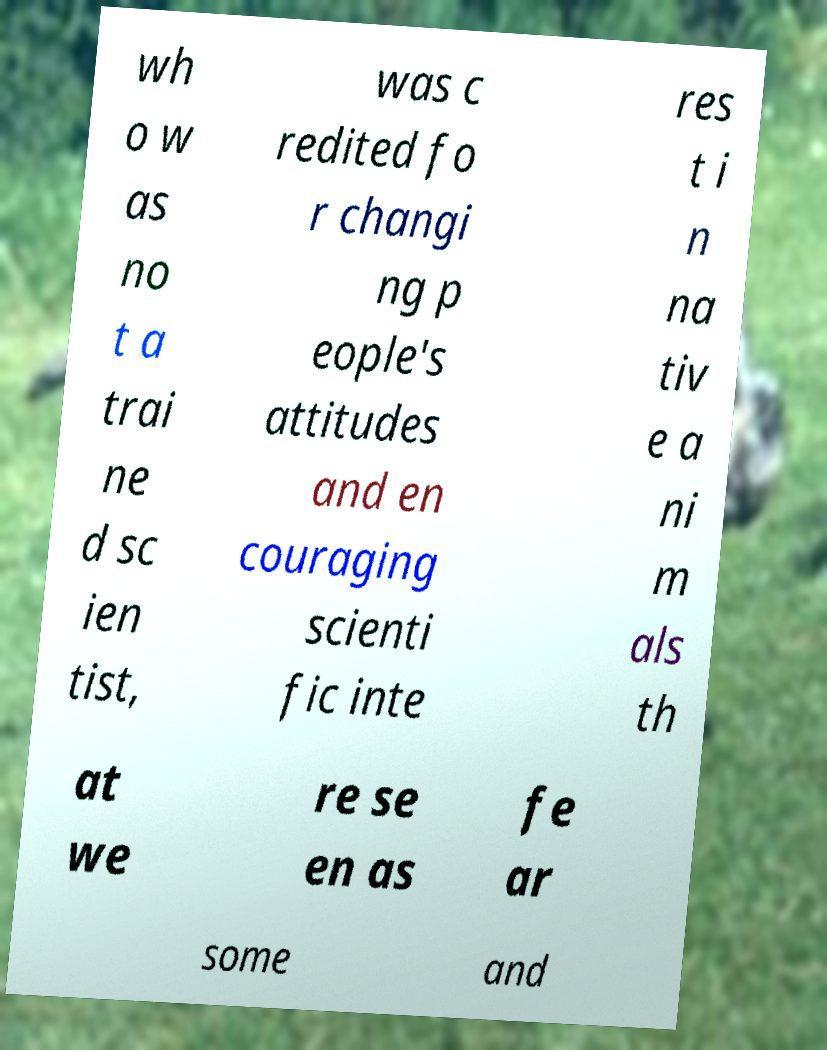I need the written content from this picture converted into text. Can you do that? wh o w as no t a trai ne d sc ien tist, was c redited fo r changi ng p eople's attitudes and en couraging scienti fic inte res t i n na tiv e a ni m als th at we re se en as fe ar some and 